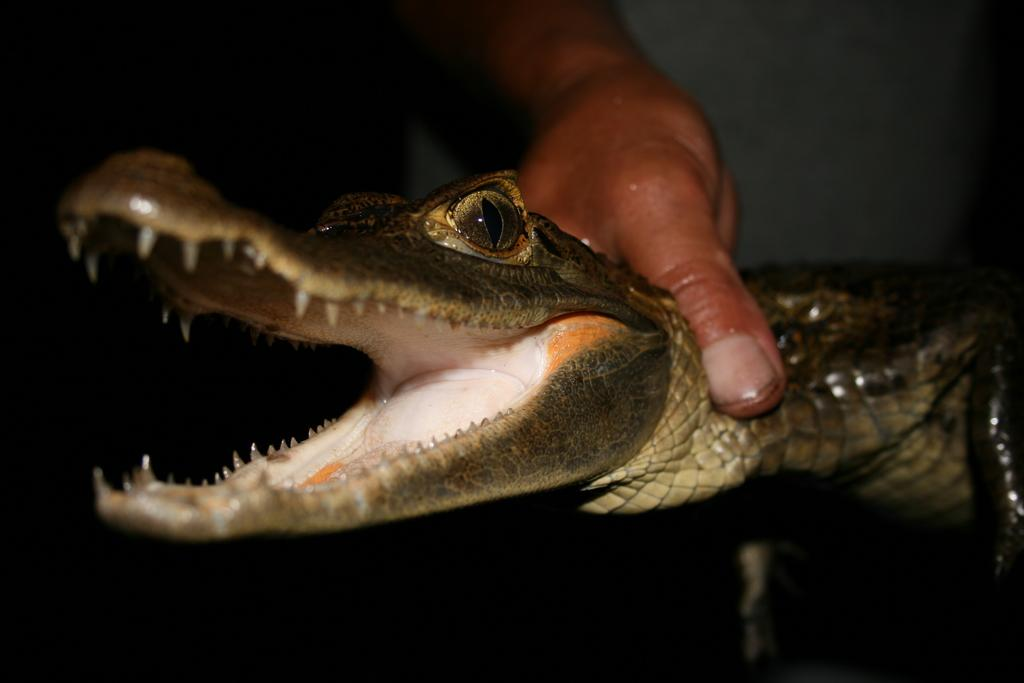What is present in the image that serves as a background or barrier? There is a wall in the image. What activity is taking place in the image? There is a person holding an animal in the image. What day of the week is depicted in the image? The day of the week is not depicted in the image, as it is a still photograph and does not convey time in that manner. What type of destruction can be seen in the image? There is no destruction present in the image; it features a person holding an animal and a wall in the background. 